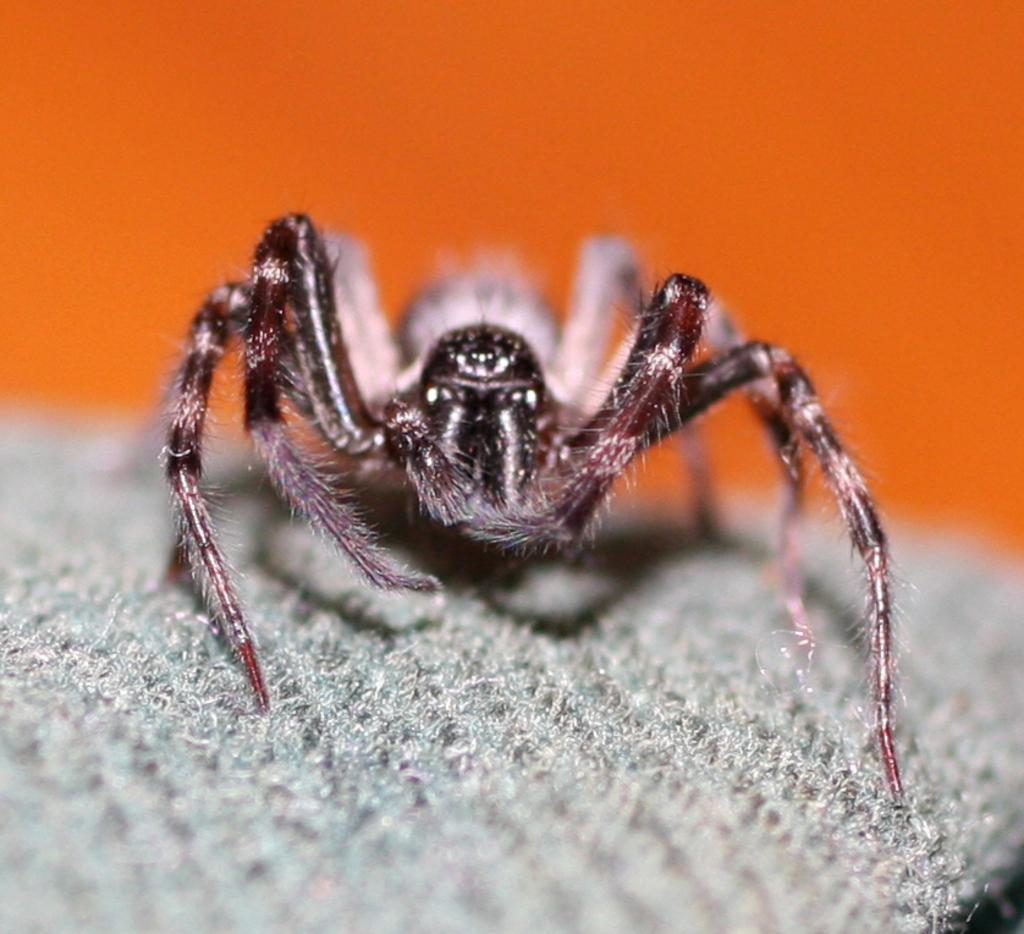What is present on the cloth in the image? There is an insect on the cloth in the image. What can be seen in the background of the image? There is a wall in the background of the image. Where is the entrance to the cellar in the image? There is no cellar or entrance to a cellar present in the image. Can you see any fairies flying around the insect in the image? There are no fairies present in the image. 